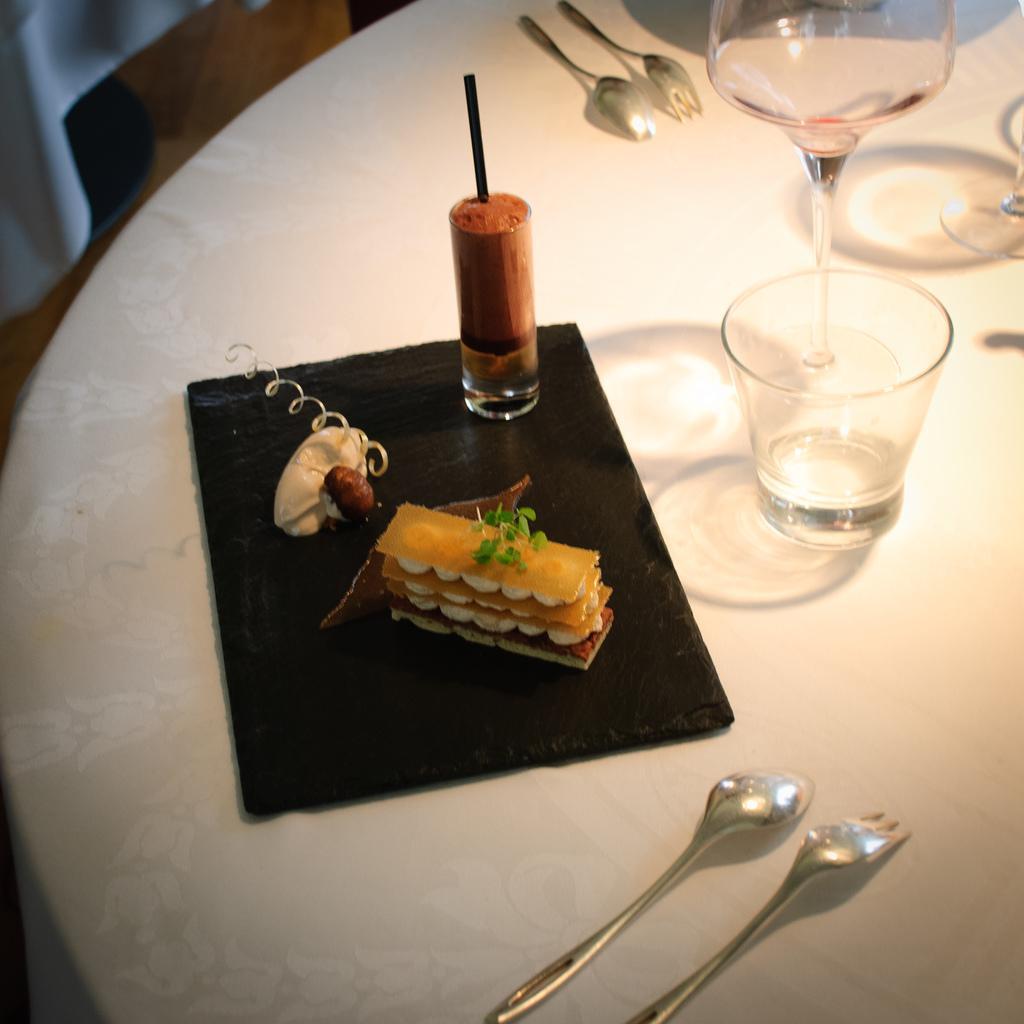Describe this image in one or two sentences. In this picture i could see a white colored dining table, on the dining table there is some desert placed on the black color plate and beside the desert there is a drink with straw in it and beside this plate there are glass and wine glass spoons and fork placed on the dining table. To the left corner of the picture i could see some white colored curtain and brown colored floor. 